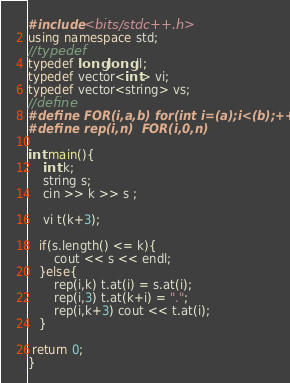Convert code to text. <code><loc_0><loc_0><loc_500><loc_500><_C++_>#include <bits/stdc++.h>
using namespace std;
//typedef
typedef long long ll;
typedef vector<int> vi;
typedef vector<string> vs;
//define
#define FOR(i,a,b) for(int i=(a);i<(b);++i)
#define rep(i,n)  FOR(i,0,n)

int main(){
    int k;
    string s;
    cin >> k >> s ;

    vi t(k+3);
   
   if(s.length() <= k){
       cout << s << endl;
   }else{
       rep(i,k) t.at(i) = s.at(i);
       rep(i,3) t.at(k+i) = ".";
       rep(i,k+3) cout << t.at(i);
   }

 return 0;
}</code> 